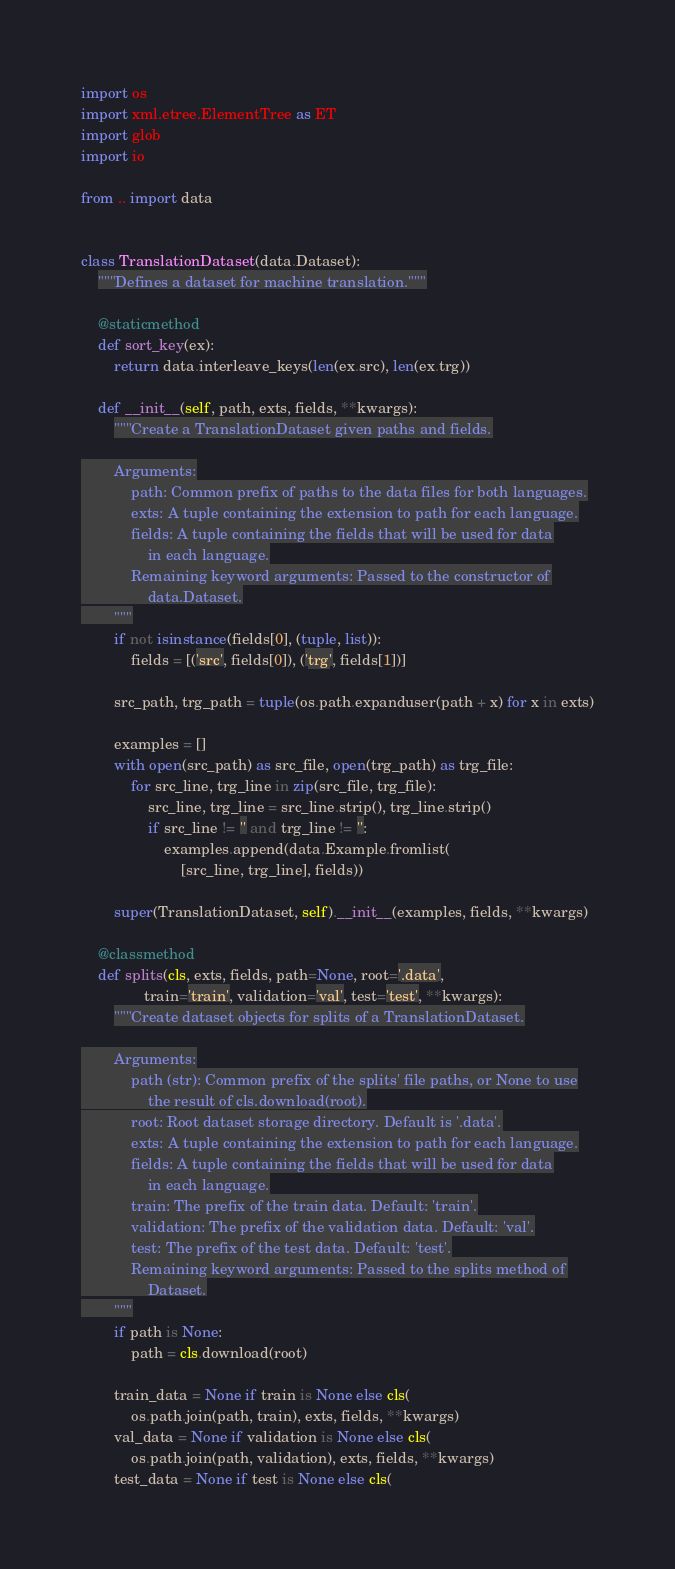<code> <loc_0><loc_0><loc_500><loc_500><_Python_>import os
import xml.etree.ElementTree as ET
import glob
import io

from .. import data


class TranslationDataset(data.Dataset):
    """Defines a dataset for machine translation."""

    @staticmethod
    def sort_key(ex):
        return data.interleave_keys(len(ex.src), len(ex.trg))

    def __init__(self, path, exts, fields, **kwargs):
        """Create a TranslationDataset given paths and fields.

        Arguments:
            path: Common prefix of paths to the data files for both languages.
            exts: A tuple containing the extension to path for each language.
            fields: A tuple containing the fields that will be used for data
                in each language.
            Remaining keyword arguments: Passed to the constructor of
                data.Dataset.
        """
        if not isinstance(fields[0], (tuple, list)):
            fields = [('src', fields[0]), ('trg', fields[1])]

        src_path, trg_path = tuple(os.path.expanduser(path + x) for x in exts)

        examples = []
        with open(src_path) as src_file, open(trg_path) as trg_file:
            for src_line, trg_line in zip(src_file, trg_file):
                src_line, trg_line = src_line.strip(), trg_line.strip()
                if src_line != '' and trg_line != '':
                    examples.append(data.Example.fromlist(
                        [src_line, trg_line], fields))

        super(TranslationDataset, self).__init__(examples, fields, **kwargs)

    @classmethod
    def splits(cls, exts, fields, path=None, root='.data',
               train='train', validation='val', test='test', **kwargs):
        """Create dataset objects for splits of a TranslationDataset.

        Arguments:
            path (str): Common prefix of the splits' file paths, or None to use
                the result of cls.download(root).
            root: Root dataset storage directory. Default is '.data'.
            exts: A tuple containing the extension to path for each language.
            fields: A tuple containing the fields that will be used for data
                in each language.
            train: The prefix of the train data. Default: 'train'.
            validation: The prefix of the validation data. Default: 'val'.
            test: The prefix of the test data. Default: 'test'.
            Remaining keyword arguments: Passed to the splits method of
                Dataset.
        """
        if path is None:
            path = cls.download(root)

        train_data = None if train is None else cls(
            os.path.join(path, train), exts, fields, **kwargs)
        val_data = None if validation is None else cls(
            os.path.join(path, validation), exts, fields, **kwargs)
        test_data = None if test is None else cls(</code> 